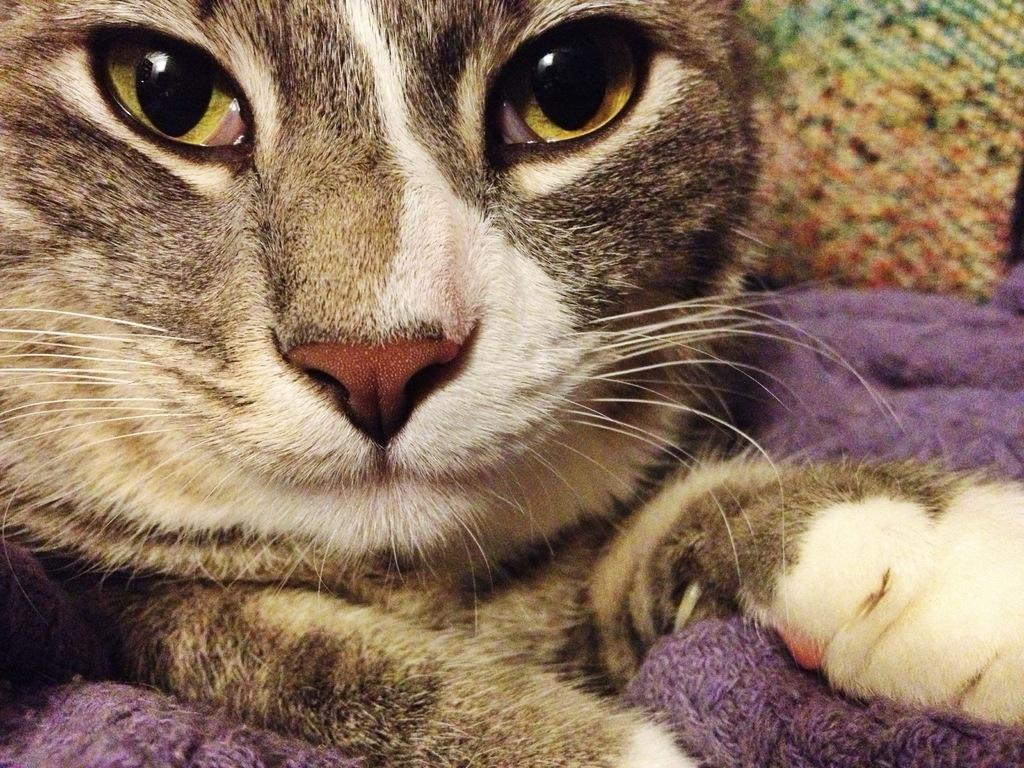What type of animal face is depicted in the image? There is a cat face in the image. What material is present in the image? There is cloth in the image. How many bridges can be seen crossing the river in the image? There are no bridges present in the image; it only features a cat face and cloth. What type of vehicle is parked near the cat face in the image? There is no van or any other vehicle present in the image. 